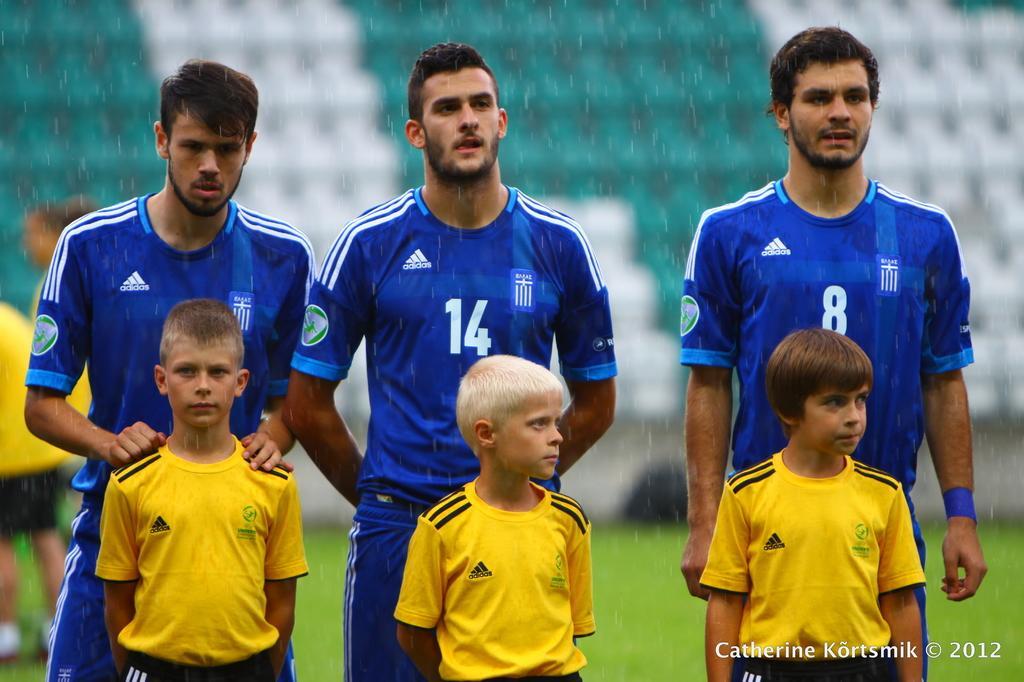In one or two sentences, can you explain what this image depicts? In this picture I can see there are three men standing and along with them there are three boys standing and the men are wearing blue jersey´s and the kids are wearing yellow jersey´s. They are standing in the playground and there's grass on the floor. It is raining and there is a logo on the right bottom of the picture. 